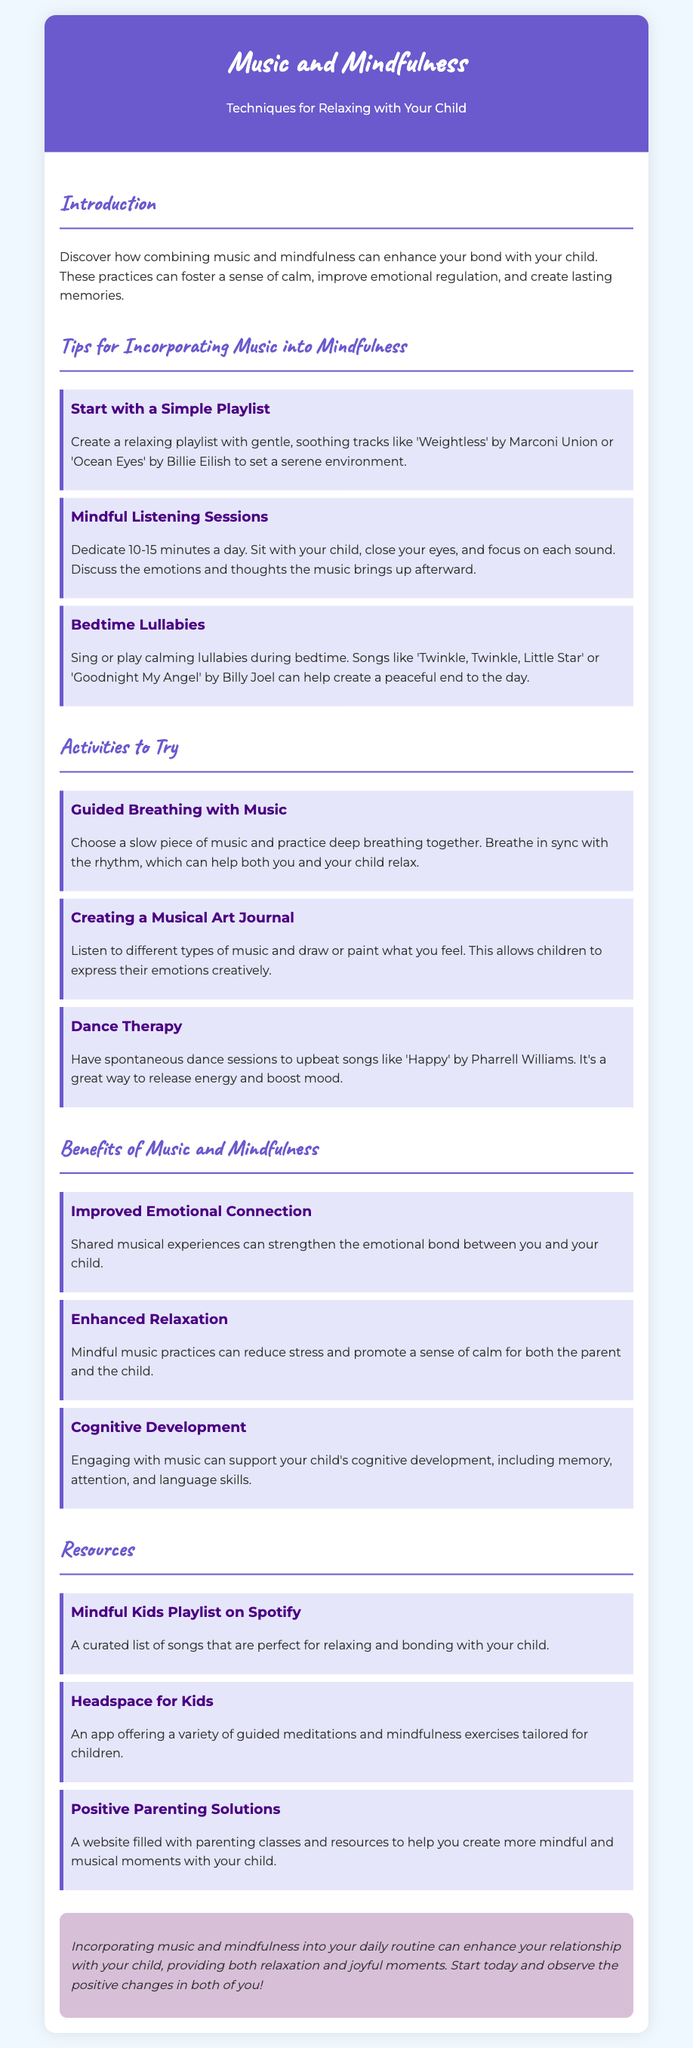What is the title of the flyer? The title of the flyer is prominently displayed in the header section.
Answer: Music and Mindfulness What is the main theme of the flyer? The main theme is described in the introductory paragraph, focusing on the combination of two specific practices.
Answer: Techniques for Relaxing with Your Child Name one song suggested for the simple playlist. The document lists specific songs under the tips section, where one is mentioned as an example.
Answer: Weightless How long should the mindful listening sessions last? The duration for the listening sessions is specified in the relevant tip on mindful listening.
Answer: 10-15 minutes What is one benefit of combining music and mindfulness? This benefit is listed under the benefits section, emphasizing the effect on emotional connections.
Answer: Improved Emotional Connection Which app is mentioned as a resource for mindfulness exercises? The app is introduced in the resources section of the flyer.
Answer: Headspace for Kids What type of painting activity is suggested alongside music? The specific activity combining listening with creative expression is outlined in the activities section.
Answer: Creating a Musical Art Journal How does music facilitate cognitive development? The document highlights a specific outcome related to engaging with music in the benefits section.
Answer: Memory, attention, and language skills What background color is used in the header? The background color of the header section is mentioned in the style within the document.
Answer: #6a5acd 